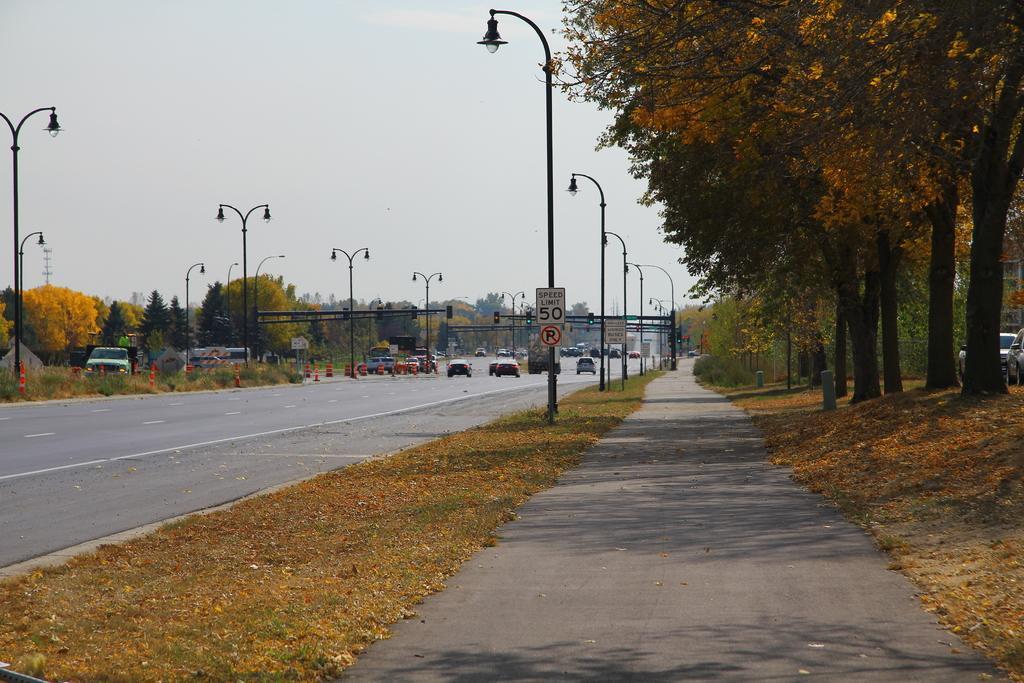Describe this image in one or two sentences. In this image I can see the road, few leaves on the ground, few street light poles, few boards attached to the poles, few vehicles on the road, few traffic poles and few trees which are green and yellow in color. In the background I can see the sky. 